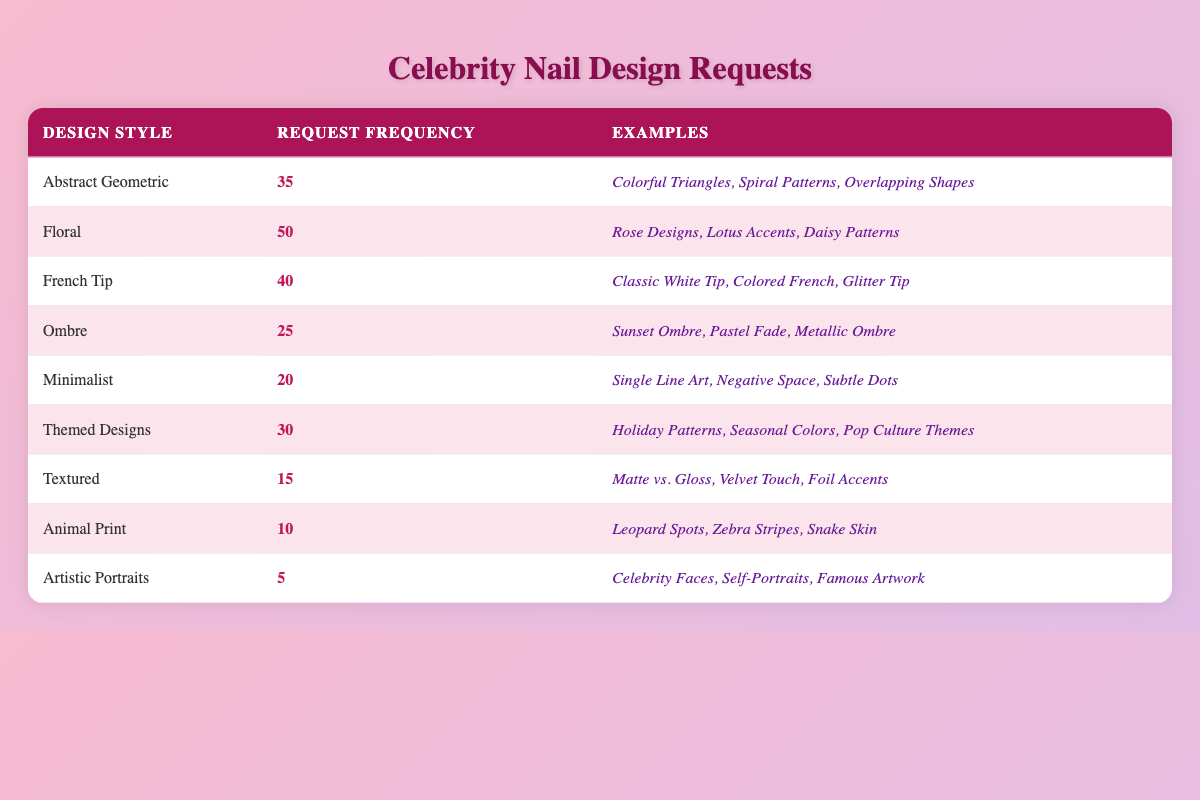What design style has the highest request frequency? By looking at the table, "Floral" has the highest request frequency at 50.
Answer: Floral How many total requests were made for Abstract Geometric and French Tip styles combined? The request frequency for Abstract Geometric is 35 and for French Tip is 40. Adding them gives 35 + 40 = 75.
Answer: 75 Which design style has the least number of requests? The design style with the least number of requests is "Artistic Portraits" with a frequency of 5.
Answer: Artistic Portraits What is the average request frequency across all design styles? To find the average, sum all the request frequencies: 35 + 50 + 40 + 25 + 20 + 30 + 15 + 10 + 5 = 230. There are 9 styles, so the average is 230 / 9 = approximately 25.56.
Answer: Approximately 25.56 Is the request frequency for Textured designs more than or equal to the request frequency for Ombre designs? Textured designs have a request frequency of 15 while Ombre has 25. Since 15 is less than 25, the statement is false.
Answer: No How many more requests were made for Floral than for Animal Print designs? Floral designs have 50 requests and Animal Print has 10 requests. Subtracting gives 50 - 10 = 40.
Answer: 40 Which design styles have a request frequency of 30 or higher? The styles with a frequency of 30 or more are Floral (50), French Tip (40), and Abstract Geometric (35).
Answer: Floral, French Tip, Abstract Geometric What is the difference in request frequency between the most popular design and the least popular design? The most popular design is Floral with 50 requests and the least popular is Artistic Portraits with 5 requests. The difference is 50 - 5 = 45.
Answer: 45 Are there more requests for Minimalist designs or Textured designs? Minimalist designs have 20 requests, whereas Textured designs have 15. Since 20 is greater than 15, the statement is true.
Answer: Yes What percentage of total requests does the Ombre design style represent? The total requests, as previously calculated, is 230. Ombre requests are 25. The percentage is (25 / 230) * 100 = approximately 10.87%.
Answer: Approximately 10.87% 